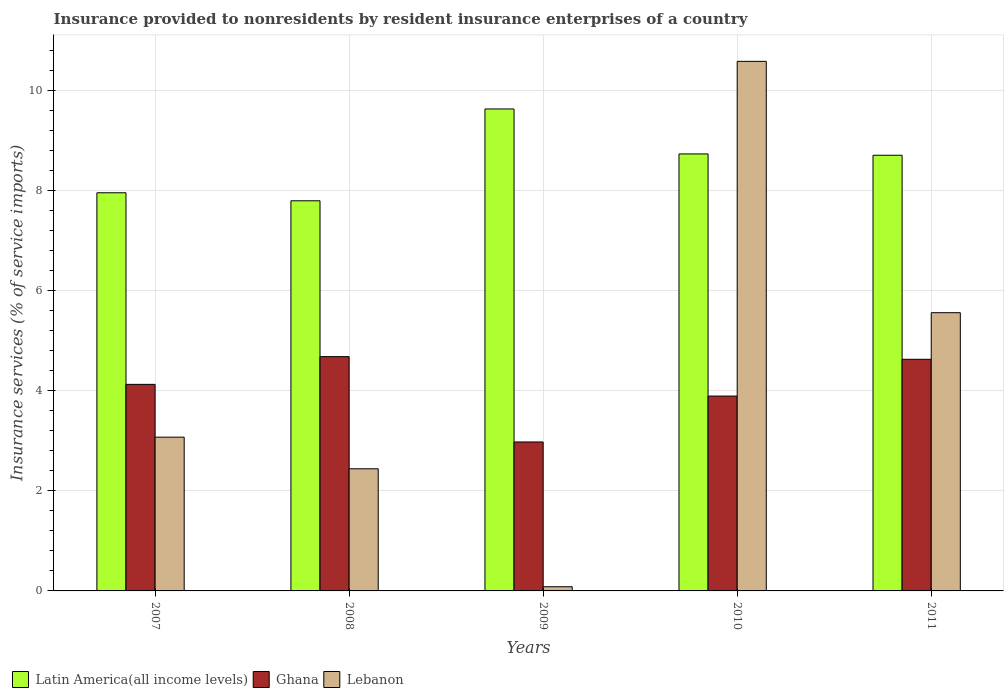How many groups of bars are there?
Keep it short and to the point. 5. Are the number of bars per tick equal to the number of legend labels?
Offer a terse response. Yes. Are the number of bars on each tick of the X-axis equal?
Give a very brief answer. Yes. How many bars are there on the 1st tick from the right?
Provide a short and direct response. 3. What is the insurance provided to nonresidents in Latin America(all income levels) in 2010?
Your response must be concise. 8.73. Across all years, what is the maximum insurance provided to nonresidents in Lebanon?
Your answer should be compact. 10.58. Across all years, what is the minimum insurance provided to nonresidents in Latin America(all income levels)?
Your answer should be very brief. 7.8. In which year was the insurance provided to nonresidents in Lebanon maximum?
Offer a very short reply. 2010. In which year was the insurance provided to nonresidents in Lebanon minimum?
Provide a succinct answer. 2009. What is the total insurance provided to nonresidents in Ghana in the graph?
Your answer should be compact. 20.31. What is the difference between the insurance provided to nonresidents in Latin America(all income levels) in 2009 and that in 2010?
Provide a succinct answer. 0.9. What is the difference between the insurance provided to nonresidents in Lebanon in 2007 and the insurance provided to nonresidents in Latin America(all income levels) in 2011?
Provide a short and direct response. -5.63. What is the average insurance provided to nonresidents in Latin America(all income levels) per year?
Keep it short and to the point. 8.57. In the year 2009, what is the difference between the insurance provided to nonresidents in Latin America(all income levels) and insurance provided to nonresidents in Ghana?
Ensure brevity in your answer.  6.66. In how many years, is the insurance provided to nonresidents in Ghana greater than 4.8 %?
Offer a very short reply. 0. What is the ratio of the insurance provided to nonresidents in Latin America(all income levels) in 2008 to that in 2009?
Offer a very short reply. 0.81. Is the difference between the insurance provided to nonresidents in Latin America(all income levels) in 2009 and 2011 greater than the difference between the insurance provided to nonresidents in Ghana in 2009 and 2011?
Give a very brief answer. Yes. What is the difference between the highest and the second highest insurance provided to nonresidents in Latin America(all income levels)?
Provide a short and direct response. 0.9. What is the difference between the highest and the lowest insurance provided to nonresidents in Ghana?
Your answer should be very brief. 1.71. What does the 2nd bar from the right in 2009 represents?
Your answer should be compact. Ghana. Are all the bars in the graph horizontal?
Give a very brief answer. No. Are the values on the major ticks of Y-axis written in scientific E-notation?
Offer a terse response. No. Does the graph contain any zero values?
Provide a short and direct response. No. Where does the legend appear in the graph?
Offer a terse response. Bottom left. How many legend labels are there?
Keep it short and to the point. 3. How are the legend labels stacked?
Provide a short and direct response. Horizontal. What is the title of the graph?
Your answer should be compact. Insurance provided to nonresidents by resident insurance enterprises of a country. Does "Peru" appear as one of the legend labels in the graph?
Provide a short and direct response. No. What is the label or title of the X-axis?
Give a very brief answer. Years. What is the label or title of the Y-axis?
Provide a succinct answer. Insurance services (% of service imports). What is the Insurance services (% of service imports) of Latin America(all income levels) in 2007?
Give a very brief answer. 7.96. What is the Insurance services (% of service imports) of Ghana in 2007?
Offer a very short reply. 4.13. What is the Insurance services (% of service imports) in Lebanon in 2007?
Make the answer very short. 3.07. What is the Insurance services (% of service imports) of Latin America(all income levels) in 2008?
Your answer should be compact. 7.8. What is the Insurance services (% of service imports) in Ghana in 2008?
Ensure brevity in your answer.  4.68. What is the Insurance services (% of service imports) of Lebanon in 2008?
Your answer should be compact. 2.44. What is the Insurance services (% of service imports) in Latin America(all income levels) in 2009?
Keep it short and to the point. 9.63. What is the Insurance services (% of service imports) in Ghana in 2009?
Keep it short and to the point. 2.98. What is the Insurance services (% of service imports) of Lebanon in 2009?
Offer a terse response. 0.08. What is the Insurance services (% of service imports) in Latin America(all income levels) in 2010?
Offer a very short reply. 8.73. What is the Insurance services (% of service imports) in Ghana in 2010?
Make the answer very short. 3.89. What is the Insurance services (% of service imports) in Lebanon in 2010?
Your response must be concise. 10.58. What is the Insurance services (% of service imports) of Latin America(all income levels) in 2011?
Your answer should be compact. 8.71. What is the Insurance services (% of service imports) in Ghana in 2011?
Offer a terse response. 4.63. What is the Insurance services (% of service imports) in Lebanon in 2011?
Provide a short and direct response. 5.56. Across all years, what is the maximum Insurance services (% of service imports) in Latin America(all income levels)?
Offer a very short reply. 9.63. Across all years, what is the maximum Insurance services (% of service imports) of Ghana?
Provide a short and direct response. 4.68. Across all years, what is the maximum Insurance services (% of service imports) of Lebanon?
Your answer should be compact. 10.58. Across all years, what is the minimum Insurance services (% of service imports) of Latin America(all income levels)?
Give a very brief answer. 7.8. Across all years, what is the minimum Insurance services (% of service imports) of Ghana?
Offer a terse response. 2.98. Across all years, what is the minimum Insurance services (% of service imports) of Lebanon?
Your answer should be very brief. 0.08. What is the total Insurance services (% of service imports) of Latin America(all income levels) in the graph?
Ensure brevity in your answer.  42.83. What is the total Insurance services (% of service imports) in Ghana in the graph?
Give a very brief answer. 20.31. What is the total Insurance services (% of service imports) of Lebanon in the graph?
Offer a terse response. 21.74. What is the difference between the Insurance services (% of service imports) of Latin America(all income levels) in 2007 and that in 2008?
Ensure brevity in your answer.  0.16. What is the difference between the Insurance services (% of service imports) of Ghana in 2007 and that in 2008?
Offer a terse response. -0.55. What is the difference between the Insurance services (% of service imports) in Lebanon in 2007 and that in 2008?
Your response must be concise. 0.63. What is the difference between the Insurance services (% of service imports) of Latin America(all income levels) in 2007 and that in 2009?
Keep it short and to the point. -1.68. What is the difference between the Insurance services (% of service imports) of Ghana in 2007 and that in 2009?
Offer a terse response. 1.15. What is the difference between the Insurance services (% of service imports) in Lebanon in 2007 and that in 2009?
Give a very brief answer. 2.99. What is the difference between the Insurance services (% of service imports) of Latin America(all income levels) in 2007 and that in 2010?
Your answer should be compact. -0.78. What is the difference between the Insurance services (% of service imports) in Ghana in 2007 and that in 2010?
Ensure brevity in your answer.  0.23. What is the difference between the Insurance services (% of service imports) of Lebanon in 2007 and that in 2010?
Offer a terse response. -7.51. What is the difference between the Insurance services (% of service imports) in Latin America(all income levels) in 2007 and that in 2011?
Provide a short and direct response. -0.75. What is the difference between the Insurance services (% of service imports) in Ghana in 2007 and that in 2011?
Give a very brief answer. -0.5. What is the difference between the Insurance services (% of service imports) of Lebanon in 2007 and that in 2011?
Keep it short and to the point. -2.49. What is the difference between the Insurance services (% of service imports) of Latin America(all income levels) in 2008 and that in 2009?
Give a very brief answer. -1.84. What is the difference between the Insurance services (% of service imports) of Ghana in 2008 and that in 2009?
Offer a terse response. 1.71. What is the difference between the Insurance services (% of service imports) in Lebanon in 2008 and that in 2009?
Ensure brevity in your answer.  2.36. What is the difference between the Insurance services (% of service imports) of Latin America(all income levels) in 2008 and that in 2010?
Give a very brief answer. -0.94. What is the difference between the Insurance services (% of service imports) in Ghana in 2008 and that in 2010?
Provide a succinct answer. 0.79. What is the difference between the Insurance services (% of service imports) of Lebanon in 2008 and that in 2010?
Your answer should be very brief. -8.14. What is the difference between the Insurance services (% of service imports) in Latin America(all income levels) in 2008 and that in 2011?
Ensure brevity in your answer.  -0.91. What is the difference between the Insurance services (% of service imports) of Ghana in 2008 and that in 2011?
Ensure brevity in your answer.  0.05. What is the difference between the Insurance services (% of service imports) of Lebanon in 2008 and that in 2011?
Your answer should be compact. -3.12. What is the difference between the Insurance services (% of service imports) of Latin America(all income levels) in 2009 and that in 2010?
Offer a terse response. 0.9. What is the difference between the Insurance services (% of service imports) of Ghana in 2009 and that in 2010?
Offer a very short reply. -0.92. What is the difference between the Insurance services (% of service imports) of Lebanon in 2009 and that in 2010?
Provide a short and direct response. -10.5. What is the difference between the Insurance services (% of service imports) of Latin America(all income levels) in 2009 and that in 2011?
Keep it short and to the point. 0.93. What is the difference between the Insurance services (% of service imports) in Ghana in 2009 and that in 2011?
Your response must be concise. -1.65. What is the difference between the Insurance services (% of service imports) in Lebanon in 2009 and that in 2011?
Your answer should be compact. -5.48. What is the difference between the Insurance services (% of service imports) of Latin America(all income levels) in 2010 and that in 2011?
Offer a terse response. 0.03. What is the difference between the Insurance services (% of service imports) in Ghana in 2010 and that in 2011?
Ensure brevity in your answer.  -0.74. What is the difference between the Insurance services (% of service imports) in Lebanon in 2010 and that in 2011?
Provide a succinct answer. 5.02. What is the difference between the Insurance services (% of service imports) in Latin America(all income levels) in 2007 and the Insurance services (% of service imports) in Ghana in 2008?
Your answer should be very brief. 3.27. What is the difference between the Insurance services (% of service imports) in Latin America(all income levels) in 2007 and the Insurance services (% of service imports) in Lebanon in 2008?
Keep it short and to the point. 5.52. What is the difference between the Insurance services (% of service imports) in Ghana in 2007 and the Insurance services (% of service imports) in Lebanon in 2008?
Keep it short and to the point. 1.69. What is the difference between the Insurance services (% of service imports) in Latin America(all income levels) in 2007 and the Insurance services (% of service imports) in Ghana in 2009?
Keep it short and to the point. 4.98. What is the difference between the Insurance services (% of service imports) of Latin America(all income levels) in 2007 and the Insurance services (% of service imports) of Lebanon in 2009?
Your response must be concise. 7.87. What is the difference between the Insurance services (% of service imports) of Ghana in 2007 and the Insurance services (% of service imports) of Lebanon in 2009?
Offer a very short reply. 4.04. What is the difference between the Insurance services (% of service imports) in Latin America(all income levels) in 2007 and the Insurance services (% of service imports) in Ghana in 2010?
Provide a succinct answer. 4.06. What is the difference between the Insurance services (% of service imports) in Latin America(all income levels) in 2007 and the Insurance services (% of service imports) in Lebanon in 2010?
Provide a succinct answer. -2.63. What is the difference between the Insurance services (% of service imports) of Ghana in 2007 and the Insurance services (% of service imports) of Lebanon in 2010?
Give a very brief answer. -6.46. What is the difference between the Insurance services (% of service imports) in Latin America(all income levels) in 2007 and the Insurance services (% of service imports) in Ghana in 2011?
Your answer should be compact. 3.33. What is the difference between the Insurance services (% of service imports) in Latin America(all income levels) in 2007 and the Insurance services (% of service imports) in Lebanon in 2011?
Ensure brevity in your answer.  2.4. What is the difference between the Insurance services (% of service imports) of Ghana in 2007 and the Insurance services (% of service imports) of Lebanon in 2011?
Ensure brevity in your answer.  -1.43. What is the difference between the Insurance services (% of service imports) in Latin America(all income levels) in 2008 and the Insurance services (% of service imports) in Ghana in 2009?
Your answer should be very brief. 4.82. What is the difference between the Insurance services (% of service imports) in Latin America(all income levels) in 2008 and the Insurance services (% of service imports) in Lebanon in 2009?
Your response must be concise. 7.71. What is the difference between the Insurance services (% of service imports) in Ghana in 2008 and the Insurance services (% of service imports) in Lebanon in 2009?
Give a very brief answer. 4.6. What is the difference between the Insurance services (% of service imports) in Latin America(all income levels) in 2008 and the Insurance services (% of service imports) in Ghana in 2010?
Your response must be concise. 3.9. What is the difference between the Insurance services (% of service imports) of Latin America(all income levels) in 2008 and the Insurance services (% of service imports) of Lebanon in 2010?
Offer a terse response. -2.79. What is the difference between the Insurance services (% of service imports) of Ghana in 2008 and the Insurance services (% of service imports) of Lebanon in 2010?
Keep it short and to the point. -5.9. What is the difference between the Insurance services (% of service imports) of Latin America(all income levels) in 2008 and the Insurance services (% of service imports) of Ghana in 2011?
Provide a short and direct response. 3.17. What is the difference between the Insurance services (% of service imports) of Latin America(all income levels) in 2008 and the Insurance services (% of service imports) of Lebanon in 2011?
Your answer should be compact. 2.24. What is the difference between the Insurance services (% of service imports) of Ghana in 2008 and the Insurance services (% of service imports) of Lebanon in 2011?
Offer a terse response. -0.88. What is the difference between the Insurance services (% of service imports) of Latin America(all income levels) in 2009 and the Insurance services (% of service imports) of Ghana in 2010?
Give a very brief answer. 5.74. What is the difference between the Insurance services (% of service imports) of Latin America(all income levels) in 2009 and the Insurance services (% of service imports) of Lebanon in 2010?
Make the answer very short. -0.95. What is the difference between the Insurance services (% of service imports) in Ghana in 2009 and the Insurance services (% of service imports) in Lebanon in 2010?
Make the answer very short. -7.61. What is the difference between the Insurance services (% of service imports) in Latin America(all income levels) in 2009 and the Insurance services (% of service imports) in Ghana in 2011?
Provide a short and direct response. 5. What is the difference between the Insurance services (% of service imports) of Latin America(all income levels) in 2009 and the Insurance services (% of service imports) of Lebanon in 2011?
Provide a succinct answer. 4.07. What is the difference between the Insurance services (% of service imports) in Ghana in 2009 and the Insurance services (% of service imports) in Lebanon in 2011?
Make the answer very short. -2.58. What is the difference between the Insurance services (% of service imports) in Latin America(all income levels) in 2010 and the Insurance services (% of service imports) in Ghana in 2011?
Keep it short and to the point. 4.1. What is the difference between the Insurance services (% of service imports) in Latin America(all income levels) in 2010 and the Insurance services (% of service imports) in Lebanon in 2011?
Your answer should be compact. 3.17. What is the difference between the Insurance services (% of service imports) in Ghana in 2010 and the Insurance services (% of service imports) in Lebanon in 2011?
Provide a short and direct response. -1.67. What is the average Insurance services (% of service imports) of Latin America(all income levels) per year?
Provide a succinct answer. 8.57. What is the average Insurance services (% of service imports) of Ghana per year?
Ensure brevity in your answer.  4.06. What is the average Insurance services (% of service imports) in Lebanon per year?
Provide a short and direct response. 4.35. In the year 2007, what is the difference between the Insurance services (% of service imports) of Latin America(all income levels) and Insurance services (% of service imports) of Ghana?
Offer a very short reply. 3.83. In the year 2007, what is the difference between the Insurance services (% of service imports) in Latin America(all income levels) and Insurance services (% of service imports) in Lebanon?
Ensure brevity in your answer.  4.88. In the year 2007, what is the difference between the Insurance services (% of service imports) in Ghana and Insurance services (% of service imports) in Lebanon?
Give a very brief answer. 1.06. In the year 2008, what is the difference between the Insurance services (% of service imports) of Latin America(all income levels) and Insurance services (% of service imports) of Ghana?
Provide a succinct answer. 3.12. In the year 2008, what is the difference between the Insurance services (% of service imports) of Latin America(all income levels) and Insurance services (% of service imports) of Lebanon?
Give a very brief answer. 5.36. In the year 2008, what is the difference between the Insurance services (% of service imports) in Ghana and Insurance services (% of service imports) in Lebanon?
Make the answer very short. 2.24. In the year 2009, what is the difference between the Insurance services (% of service imports) in Latin America(all income levels) and Insurance services (% of service imports) in Ghana?
Offer a very short reply. 6.66. In the year 2009, what is the difference between the Insurance services (% of service imports) of Latin America(all income levels) and Insurance services (% of service imports) of Lebanon?
Your answer should be very brief. 9.55. In the year 2009, what is the difference between the Insurance services (% of service imports) in Ghana and Insurance services (% of service imports) in Lebanon?
Keep it short and to the point. 2.89. In the year 2010, what is the difference between the Insurance services (% of service imports) of Latin America(all income levels) and Insurance services (% of service imports) of Ghana?
Make the answer very short. 4.84. In the year 2010, what is the difference between the Insurance services (% of service imports) in Latin America(all income levels) and Insurance services (% of service imports) in Lebanon?
Provide a short and direct response. -1.85. In the year 2010, what is the difference between the Insurance services (% of service imports) in Ghana and Insurance services (% of service imports) in Lebanon?
Your response must be concise. -6.69. In the year 2011, what is the difference between the Insurance services (% of service imports) in Latin America(all income levels) and Insurance services (% of service imports) in Ghana?
Offer a terse response. 4.08. In the year 2011, what is the difference between the Insurance services (% of service imports) in Latin America(all income levels) and Insurance services (% of service imports) in Lebanon?
Your answer should be compact. 3.15. In the year 2011, what is the difference between the Insurance services (% of service imports) in Ghana and Insurance services (% of service imports) in Lebanon?
Keep it short and to the point. -0.93. What is the ratio of the Insurance services (% of service imports) in Latin America(all income levels) in 2007 to that in 2008?
Your answer should be very brief. 1.02. What is the ratio of the Insurance services (% of service imports) in Ghana in 2007 to that in 2008?
Offer a terse response. 0.88. What is the ratio of the Insurance services (% of service imports) of Lebanon in 2007 to that in 2008?
Offer a very short reply. 1.26. What is the ratio of the Insurance services (% of service imports) of Latin America(all income levels) in 2007 to that in 2009?
Offer a terse response. 0.83. What is the ratio of the Insurance services (% of service imports) of Ghana in 2007 to that in 2009?
Your answer should be compact. 1.39. What is the ratio of the Insurance services (% of service imports) in Lebanon in 2007 to that in 2009?
Provide a short and direct response. 36.79. What is the ratio of the Insurance services (% of service imports) of Latin America(all income levels) in 2007 to that in 2010?
Keep it short and to the point. 0.91. What is the ratio of the Insurance services (% of service imports) in Ghana in 2007 to that in 2010?
Your answer should be very brief. 1.06. What is the ratio of the Insurance services (% of service imports) of Lebanon in 2007 to that in 2010?
Your answer should be compact. 0.29. What is the ratio of the Insurance services (% of service imports) of Latin America(all income levels) in 2007 to that in 2011?
Give a very brief answer. 0.91. What is the ratio of the Insurance services (% of service imports) of Ghana in 2007 to that in 2011?
Your answer should be compact. 0.89. What is the ratio of the Insurance services (% of service imports) in Lebanon in 2007 to that in 2011?
Your answer should be compact. 0.55. What is the ratio of the Insurance services (% of service imports) of Latin America(all income levels) in 2008 to that in 2009?
Your response must be concise. 0.81. What is the ratio of the Insurance services (% of service imports) in Ghana in 2008 to that in 2009?
Your answer should be compact. 1.57. What is the ratio of the Insurance services (% of service imports) in Lebanon in 2008 to that in 2009?
Give a very brief answer. 29.23. What is the ratio of the Insurance services (% of service imports) of Latin America(all income levels) in 2008 to that in 2010?
Ensure brevity in your answer.  0.89. What is the ratio of the Insurance services (% of service imports) in Ghana in 2008 to that in 2010?
Your answer should be compact. 1.2. What is the ratio of the Insurance services (% of service imports) in Lebanon in 2008 to that in 2010?
Give a very brief answer. 0.23. What is the ratio of the Insurance services (% of service imports) in Latin America(all income levels) in 2008 to that in 2011?
Your response must be concise. 0.9. What is the ratio of the Insurance services (% of service imports) of Ghana in 2008 to that in 2011?
Provide a succinct answer. 1.01. What is the ratio of the Insurance services (% of service imports) in Lebanon in 2008 to that in 2011?
Provide a short and direct response. 0.44. What is the ratio of the Insurance services (% of service imports) of Latin America(all income levels) in 2009 to that in 2010?
Provide a succinct answer. 1.1. What is the ratio of the Insurance services (% of service imports) of Ghana in 2009 to that in 2010?
Offer a terse response. 0.76. What is the ratio of the Insurance services (% of service imports) in Lebanon in 2009 to that in 2010?
Offer a terse response. 0.01. What is the ratio of the Insurance services (% of service imports) of Latin America(all income levels) in 2009 to that in 2011?
Your answer should be compact. 1.11. What is the ratio of the Insurance services (% of service imports) of Ghana in 2009 to that in 2011?
Your answer should be compact. 0.64. What is the ratio of the Insurance services (% of service imports) of Lebanon in 2009 to that in 2011?
Provide a succinct answer. 0.01. What is the ratio of the Insurance services (% of service imports) in Latin America(all income levels) in 2010 to that in 2011?
Your answer should be compact. 1. What is the ratio of the Insurance services (% of service imports) of Ghana in 2010 to that in 2011?
Give a very brief answer. 0.84. What is the ratio of the Insurance services (% of service imports) in Lebanon in 2010 to that in 2011?
Give a very brief answer. 1.9. What is the difference between the highest and the second highest Insurance services (% of service imports) of Latin America(all income levels)?
Offer a terse response. 0.9. What is the difference between the highest and the second highest Insurance services (% of service imports) in Ghana?
Your answer should be compact. 0.05. What is the difference between the highest and the second highest Insurance services (% of service imports) in Lebanon?
Make the answer very short. 5.02. What is the difference between the highest and the lowest Insurance services (% of service imports) in Latin America(all income levels)?
Ensure brevity in your answer.  1.84. What is the difference between the highest and the lowest Insurance services (% of service imports) in Ghana?
Offer a very short reply. 1.71. What is the difference between the highest and the lowest Insurance services (% of service imports) in Lebanon?
Offer a terse response. 10.5. 